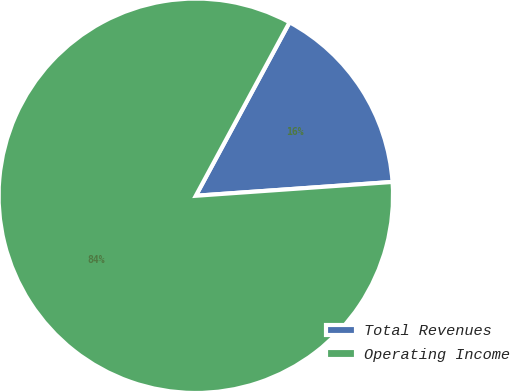Convert chart to OTSL. <chart><loc_0><loc_0><loc_500><loc_500><pie_chart><fcel>Total Revenues<fcel>Operating Income<nl><fcel>16.0%<fcel>84.0%<nl></chart> 